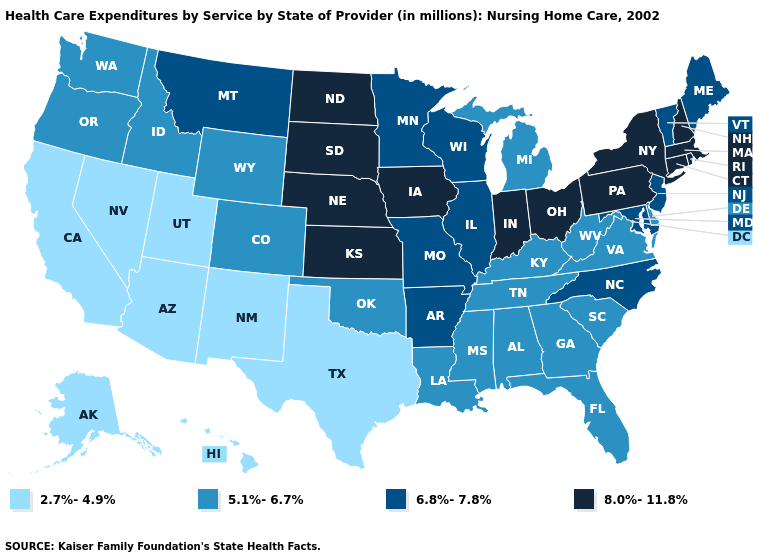What is the value of Georgia?
Write a very short answer. 5.1%-6.7%. What is the value of Louisiana?
Write a very short answer. 5.1%-6.7%. What is the value of Illinois?
Answer briefly. 6.8%-7.8%. Among the states that border Indiana , does Ohio have the highest value?
Answer briefly. Yes. What is the value of Massachusetts?
Concise answer only. 8.0%-11.8%. Does Kansas have the highest value in the USA?
Keep it brief. Yes. Does the map have missing data?
Concise answer only. No. Name the states that have a value in the range 2.7%-4.9%?
Quick response, please. Alaska, Arizona, California, Hawaii, Nevada, New Mexico, Texas, Utah. What is the lowest value in the USA?
Short answer required. 2.7%-4.9%. Name the states that have a value in the range 5.1%-6.7%?
Give a very brief answer. Alabama, Colorado, Delaware, Florida, Georgia, Idaho, Kentucky, Louisiana, Michigan, Mississippi, Oklahoma, Oregon, South Carolina, Tennessee, Virginia, Washington, West Virginia, Wyoming. Name the states that have a value in the range 8.0%-11.8%?
Give a very brief answer. Connecticut, Indiana, Iowa, Kansas, Massachusetts, Nebraska, New Hampshire, New York, North Dakota, Ohio, Pennsylvania, Rhode Island, South Dakota. What is the highest value in states that border Nebraska?
Quick response, please. 8.0%-11.8%. Does Michigan have the lowest value in the MidWest?
Short answer required. Yes. Among the states that border Oregon , does Washington have the highest value?
Be succinct. Yes. How many symbols are there in the legend?
Be succinct. 4. 